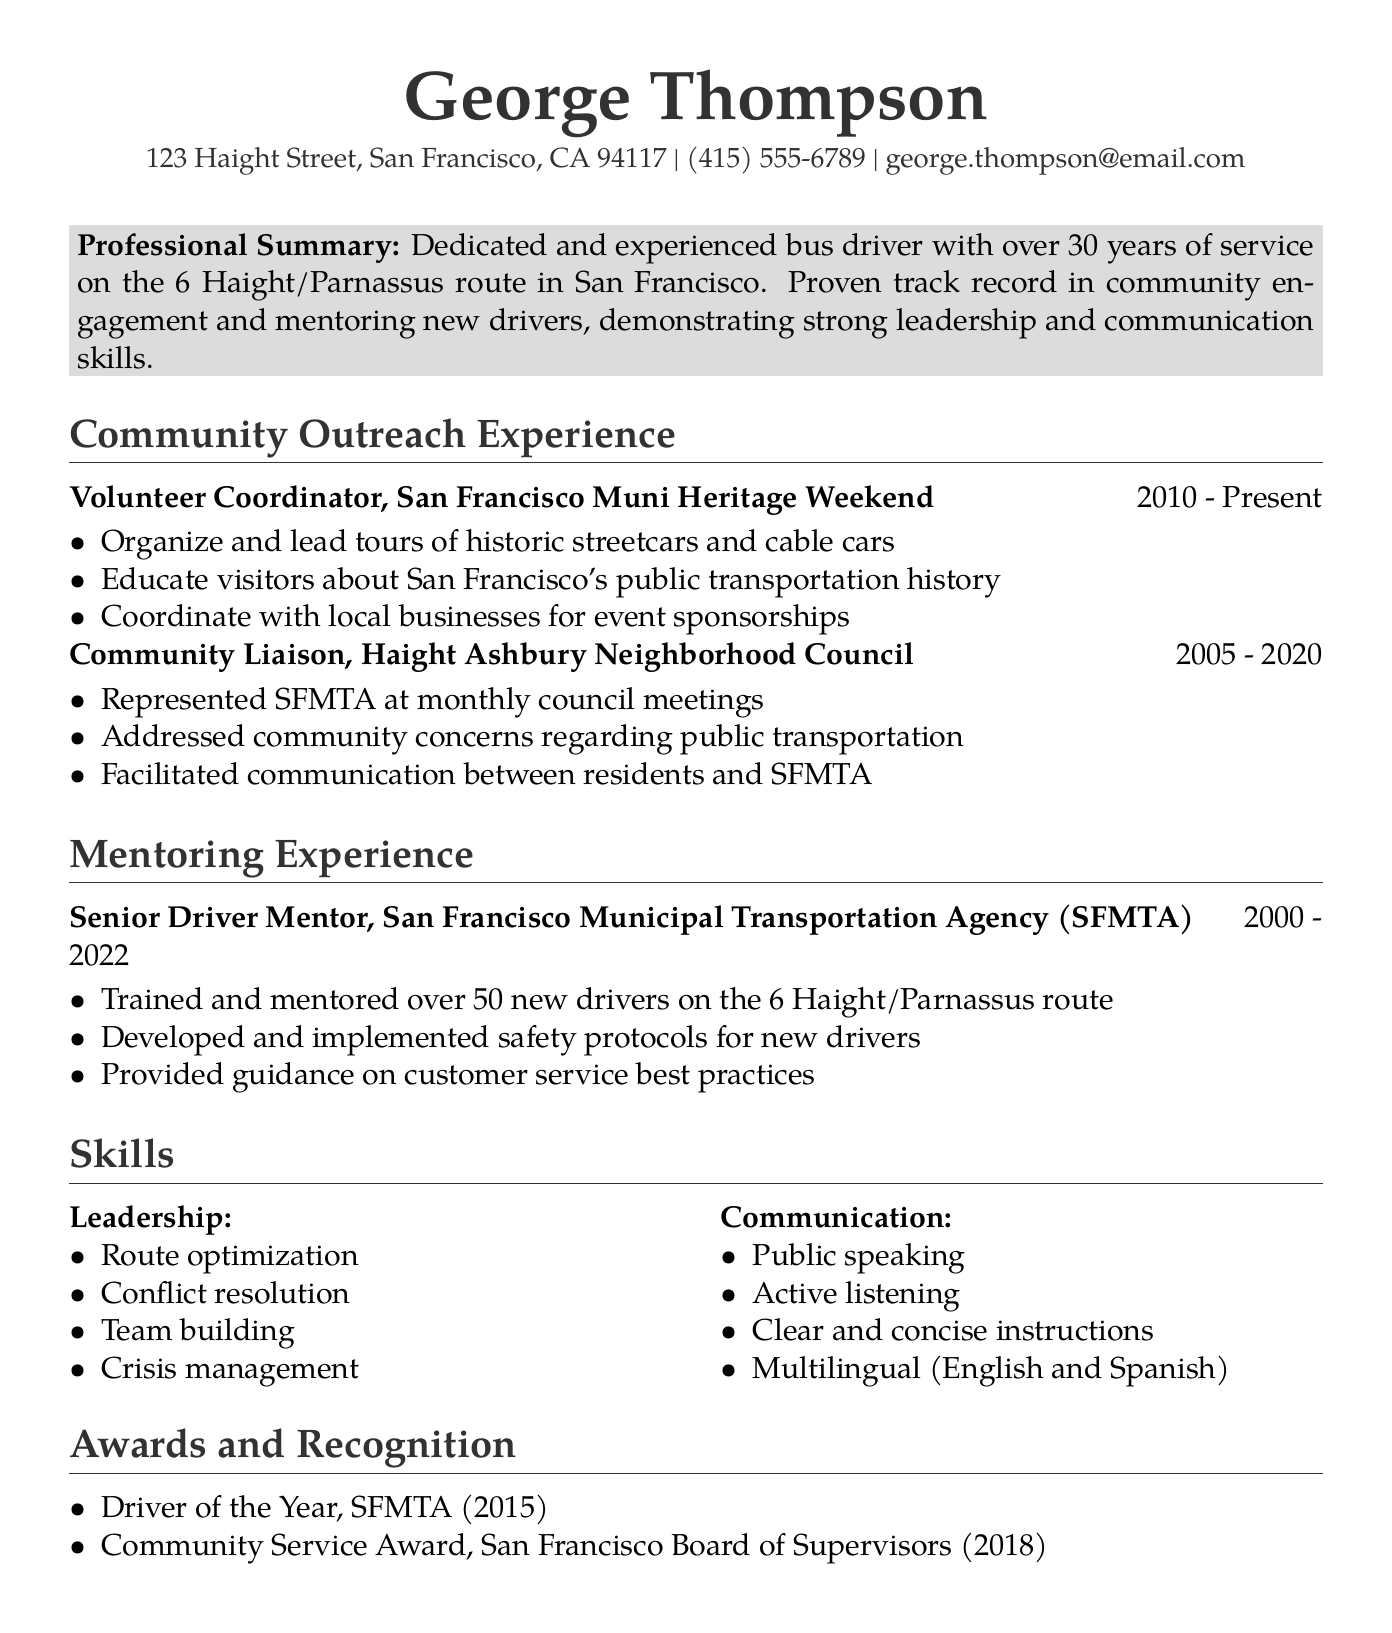What is the name of the individual? The document provides the name as the main header.
Answer: George Thompson What is the email address listed? The email address provided in the contact information section is mentioned directly.
Answer: george.thompson@email.com In which organization did George serve as a Senior Driver Mentor? The mentoring experience section specifies the organization where he worked.
Answer: San Francisco Municipal Transportation Agency How many new drivers has George trained and mentored? The mentoring experience explicitly states the number of new drivers he has trained.
Answer: over 50 What award did George receive in 2015? The awards and recognition section lists specific awards by year.
Answer: Driver of the Year During which years did George serve as Community Liaison? The duration for the Community Liaison position is explicitly provided.
Answer: 2005 - 2020 What public speaking skill does George possess? The communication skills section highlights his abilities in a specific context.
Answer: Public speaking What was George's role at the San Francisco Muni Heritage Weekend? The community outreach experience section specifies his title in this role.
Answer: Volunteer Coordinator Which two languages can George communicate in? The communication skills section indicates his language proficiency.
Answer: English and Spanish 